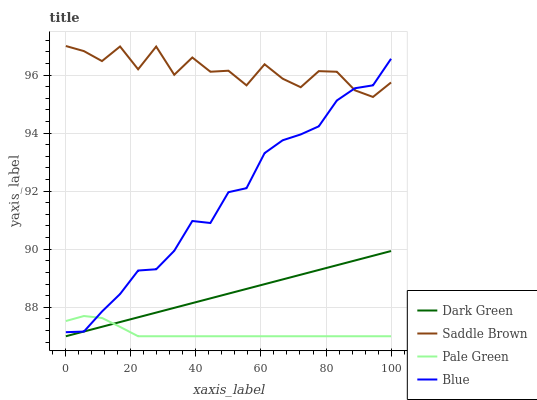Does Pale Green have the minimum area under the curve?
Answer yes or no. Yes. Does Saddle Brown have the maximum area under the curve?
Answer yes or no. Yes. Does Saddle Brown have the minimum area under the curve?
Answer yes or no. No. Does Pale Green have the maximum area under the curve?
Answer yes or no. No. Is Dark Green the smoothest?
Answer yes or no. Yes. Is Saddle Brown the roughest?
Answer yes or no. Yes. Is Pale Green the smoothest?
Answer yes or no. No. Is Pale Green the roughest?
Answer yes or no. No. Does Pale Green have the lowest value?
Answer yes or no. Yes. Does Saddle Brown have the lowest value?
Answer yes or no. No. Does Saddle Brown have the highest value?
Answer yes or no. Yes. Does Pale Green have the highest value?
Answer yes or no. No. Is Pale Green less than Saddle Brown?
Answer yes or no. Yes. Is Saddle Brown greater than Pale Green?
Answer yes or no. Yes. Does Blue intersect Pale Green?
Answer yes or no. Yes. Is Blue less than Pale Green?
Answer yes or no. No. Is Blue greater than Pale Green?
Answer yes or no. No. Does Pale Green intersect Saddle Brown?
Answer yes or no. No. 